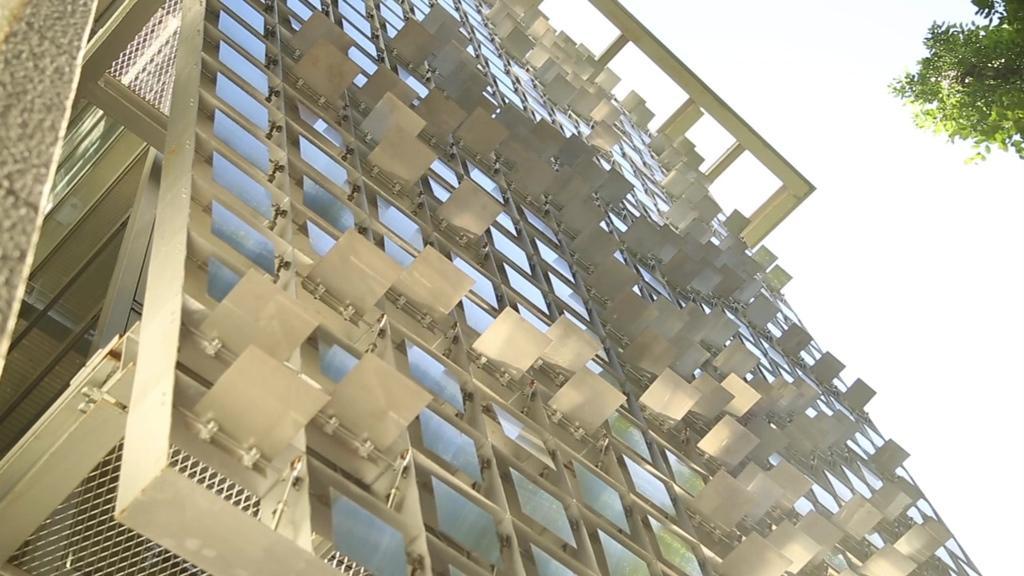Can you describe this image briefly? In this image there is a zoom in picture of a building as we can see in the middle of this image. There are some leaves of a tree on the top right corner of this image and there is a sky in the background. 